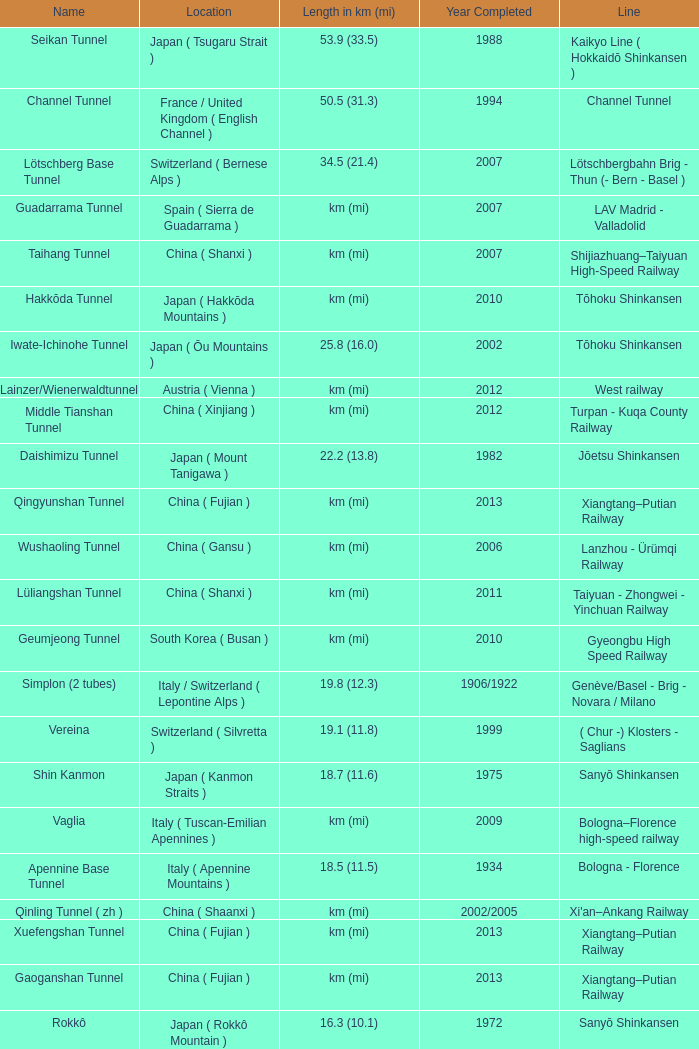What year was the Line of Gardermobanen completed? 1999.0. 